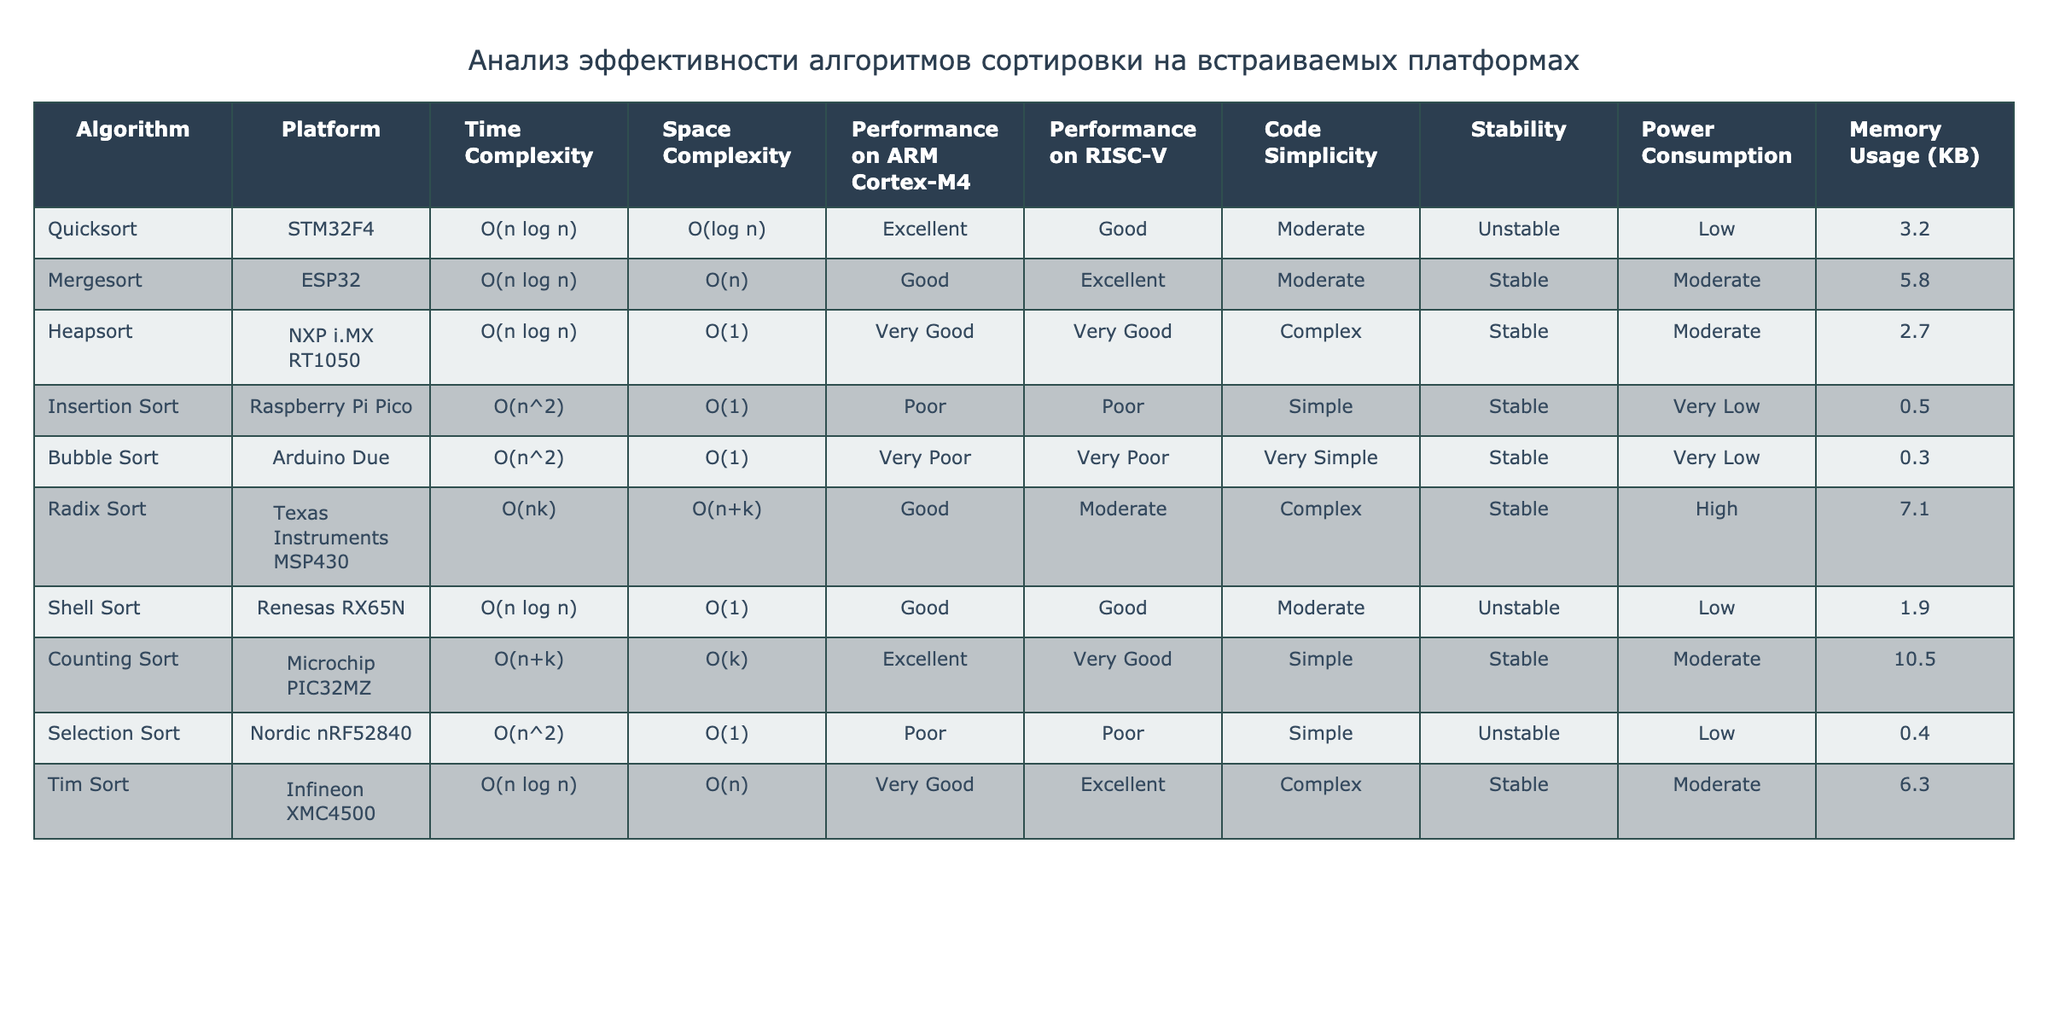What is the time complexity of Quicksort? In the table, the time complexity for Quicksort is listed right under the "Time Complexity" column. It is stated as O(n log n).
Answer: O(n log n) Which algorithm has the lowest memory usage? By examining the "Memory Usage" column, we can see that Bubble Sort has the lowest value at 0.3 KB, which is the smallest among all the listed algorithms.
Answer: 0.3 KB Is Heapsort stable? The stability of sorting algorithms is indicated in the "Stability" column. Heapsort is marked as Unstable, meaning it does not maintain the relative order of equal elements.
Answer: No Which algorithm has the best performance on ARM Cortex-M4? Looking at the "Performance on ARM Cortex-M4" column, Quicksort is rated as Excellent, making it the top performer for that specific platform.
Answer: Quicksort What is the difference in memory usage between Counting Sort and Insertion Sort? The memory usage for Counting Sort is 10.5 KB and for Insertion Sort is 0.5 KB. The difference is calculated as 10.5 - 0.5 = 10, thus Counting Sort uses 10 KB more memory than Insertion Sort.
Answer: 10 KB Are the time complexities of Mergesort and Tim Sort the same? Both algorithms are listed in the "Time Complexity" column, which shows that Mergesort has O(n log n) and Tim Sort also has O(n log n), confirming they are the same.
Answer: Yes Which sorting algorithm has excellent performance on both ARM Cortex-M4 and RISC-V platforms? By checking both "Performance on ARM Cortex-M4" and "Performance on RISC-V" columns, we observe that Mergesort achieves Excellent performance on both platforms, meeting the criteria.
Answer: Mergesort How many algorithms have a time complexity of O(n^2)? In the "Time Complexity" column, we identify three algorithms: Insertion Sort, Bubble Sort, and Selection Sort. Thus, the total number of algorithms with this time complexity is three.
Answer: 3 What is the average power consumption of the algorithms listed? The power consumption values are: Low, Moderate, Very Low, Very Low, High, Moderate, Moderate, Low, and Low. To calculate the average, we convert them into numerical factors: Low = 1, Moderate = 2, Very Low = 0.5, High = 3. Thus, (1 + 2 + 0.5 + 0.5 + 3 + 2 + 2 + 1 + 1) / 9 = 1.39.
Answer: Approximately 1.39 Is Radix Sort more power-efficient than Heapsort? By checking the "Power Consumption" column, Radix Sort has High power consumption while Heapsort has Moderate power consumption (which is less), indicating that Heapsort is more power-efficient.
Answer: No 